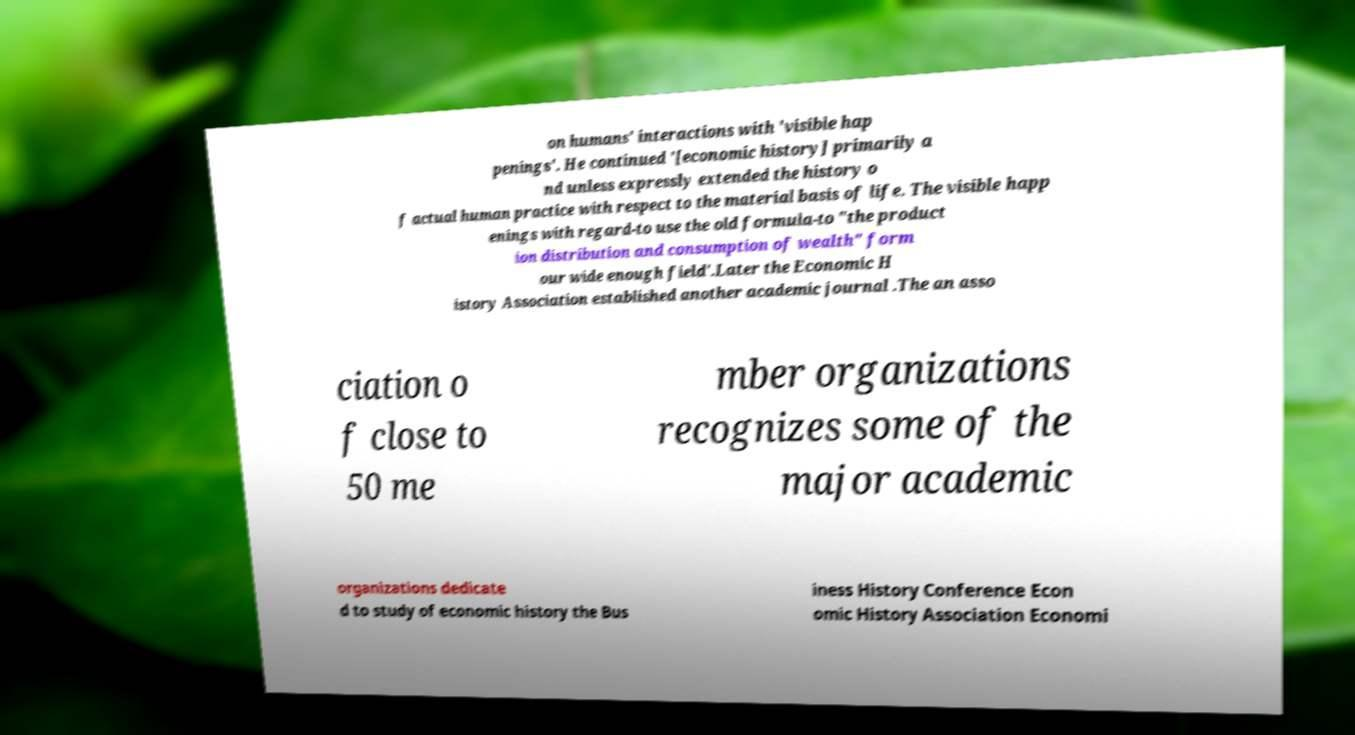Please identify and transcribe the text found in this image. on humans' interactions with 'visible hap penings'. He continued '[economic history] primarily a nd unless expressly extended the history o f actual human practice with respect to the material basis of life. The visible happ enings with regard-to use the old formula-to "the product ion distribution and consumption of wealth" form our wide enough field'.Later the Economic H istory Association established another academic journal .The an asso ciation o f close to 50 me mber organizations recognizes some of the major academic organizations dedicate d to study of economic history the Bus iness History Conference Econ omic History Association Economi 